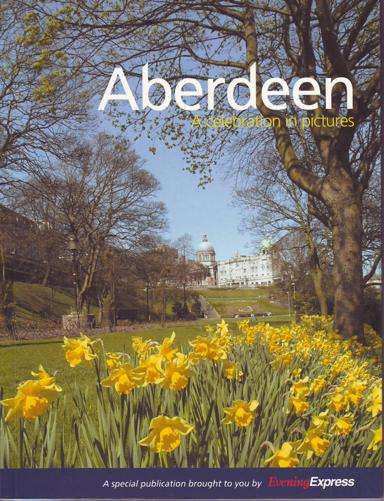What is the organization responsible for the special publication? The special publication titled "Aberdeen: A Celebration in Pictures" is brought to us by 'Evening Express,' a local news outlet known for its in-depth coverage of Aberdeen and surrounding areas. They have curated this publication to highlight the city's charm and significance through captivating photographs. 